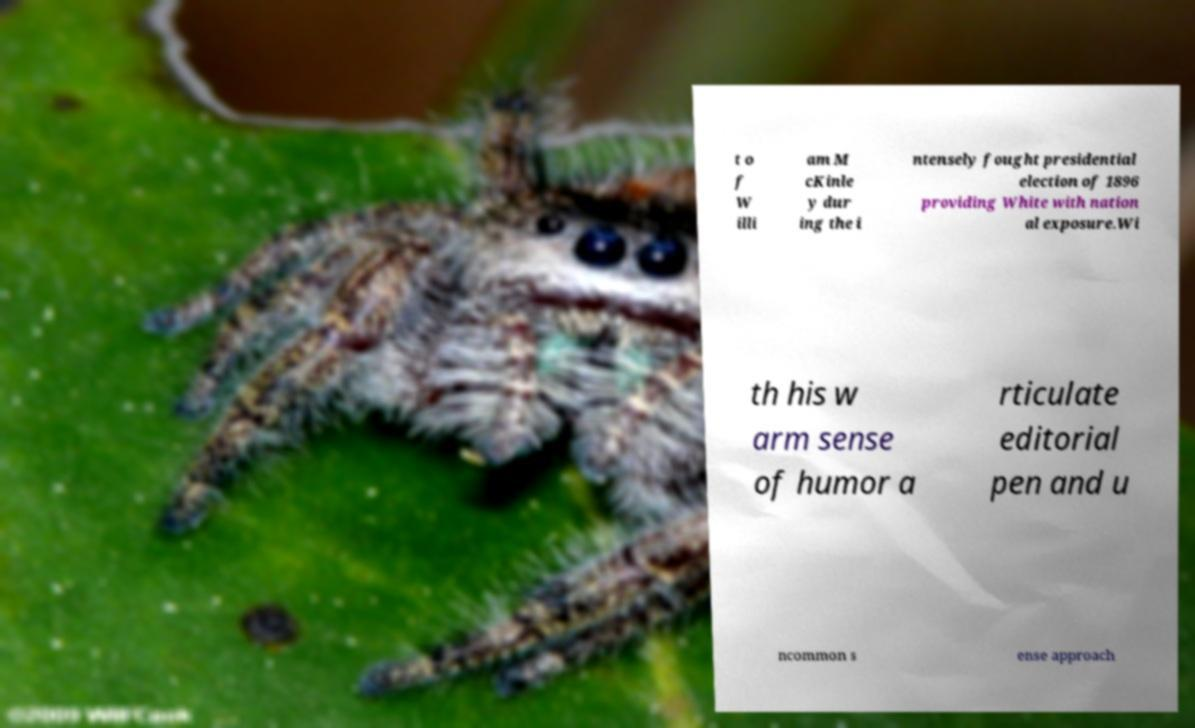There's text embedded in this image that I need extracted. Can you transcribe it verbatim? t o f W illi am M cKinle y dur ing the i ntensely fought presidential election of 1896 providing White with nation al exposure.Wi th his w arm sense of humor a rticulate editorial pen and u ncommon s ense approach 